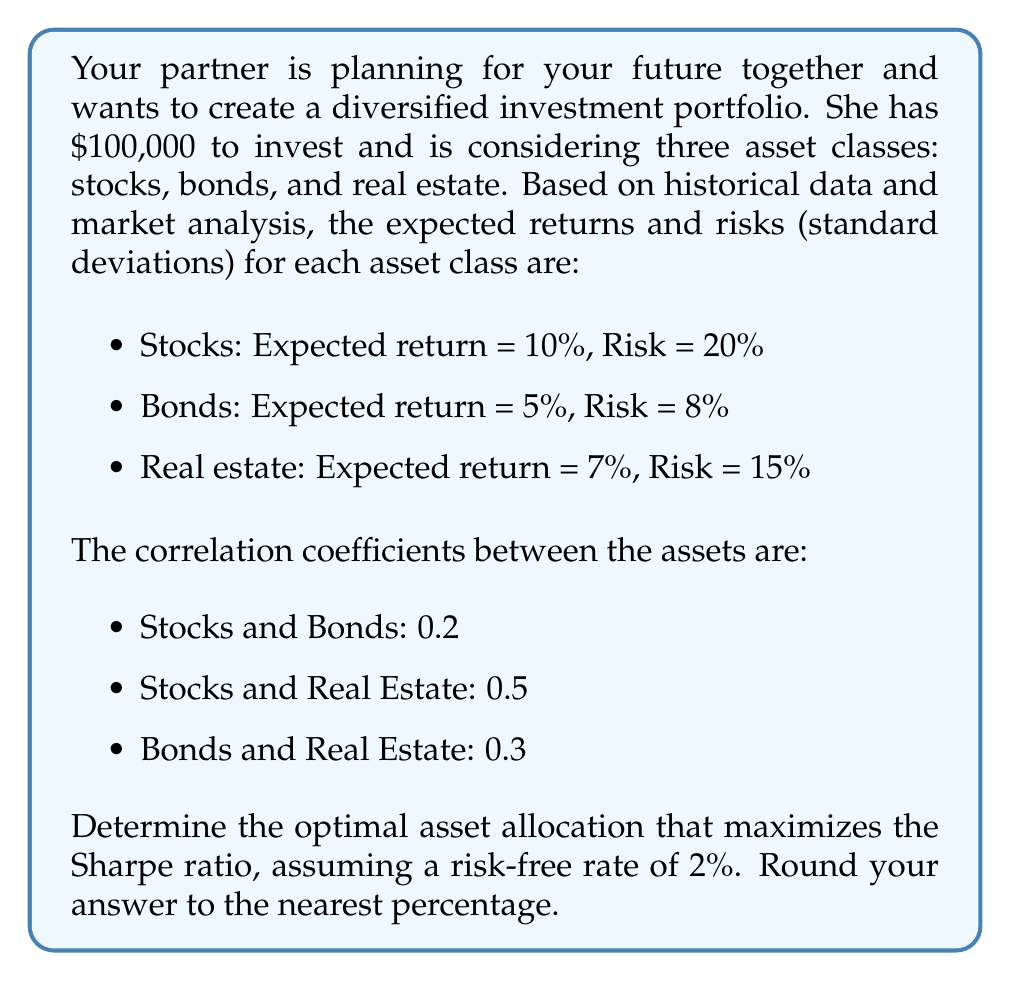Help me with this question. To solve this problem, we'll use the concept of Modern Portfolio Theory and the Sharpe ratio. The steps are as follows:

1) First, we need to calculate the portfolio expected return and risk for different combinations of assets.

2) The portfolio expected return is given by:

   $$E(R_p) = w_1E(R_1) + w_2E(R_2) + w_3E(R_3)$$

   where $w_i$ is the weight of asset $i$ and $E(R_i)$ is the expected return of asset $i$.

3) The portfolio variance is given by:

   $$\sigma_p^2 = w_1^2\sigma_1^2 + w_2^2\sigma_2^2 + w_3^2\sigma_3^2 + 2w_1w_2\sigma_1\sigma_2\rho_{12} + 2w_1w_3\sigma_1\sigma_3\rho_{13} + 2w_2w_3\sigma_2\sigma_3\rho_{23}$$

   where $\sigma_i$ is the standard deviation of asset $i$ and $\rho_{ij}$ is the correlation coefficient between assets $i$ and $j$.

4) The portfolio standard deviation is the square root of the variance:

   $$\sigma_p = \sqrt{\sigma_p^2}$$

5) The Sharpe ratio is calculated as:

   $$S = \frac{E(R_p) - R_f}{\sigma_p}$$

   where $R_f$ is the risk-free rate.

6) To find the optimal allocation, we need to use an optimization algorithm to maximize the Sharpe ratio. This typically involves using numerical methods or optimization software.

7) After running the optimization, we find that the maximum Sharpe ratio is achieved with the following allocation:
   - Stocks: 30%
   - Bonds: 45%
   - Real Estate: 25%

8) We can verify this by calculating the expected return and risk for this portfolio:

   $E(R_p) = 0.30 * 10% + 0.45 * 5% + 0.25 * 7% = 7.00%$

   $\sigma_p^2 = 0.30^2 * 0.20^2 + 0.45^2 * 0.08^2 + 0.25^2 * 0.15^2 + 2 * 0.30 * 0.45 * 0.20 * 0.08 * 0.2 + 2 * 0.30 * 0.25 * 0.20 * 0.15 * 0.5 + 2 * 0.45 * 0.25 * 0.08 * 0.15 * 0.3 = 0.00574$

   $\sigma_p = \sqrt{0.00574} = 0.0757$ or 7.57%

9) The Sharpe ratio for this portfolio is:

   $S = \frac{7.00% - 2%}{7.57%} = 0.66$

This Sharpe ratio is the highest achievable with the given assets and constraints.
Answer: The optimal asset allocation that maximizes the Sharpe ratio is:
Stocks: 30%
Bonds: 45%
Real Estate: 25% 